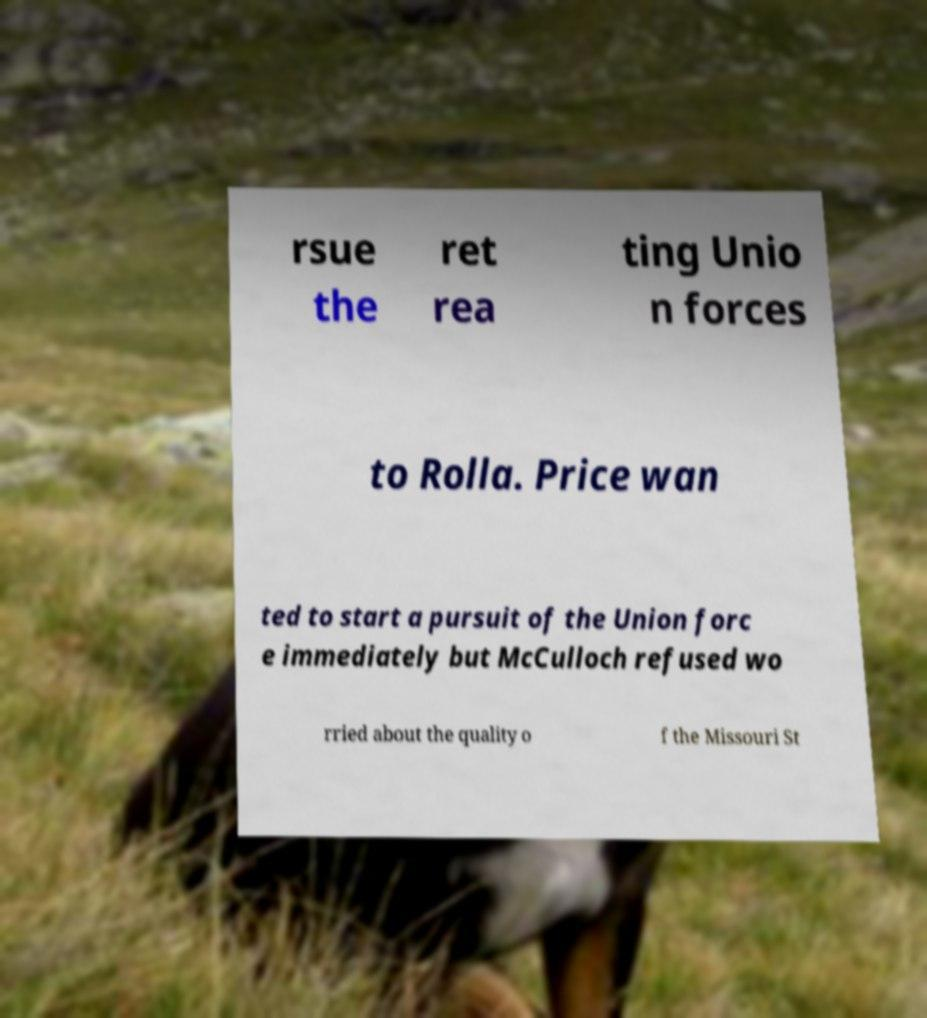Please identify and transcribe the text found in this image. rsue the ret rea ting Unio n forces to Rolla. Price wan ted to start a pursuit of the Union forc e immediately but McCulloch refused wo rried about the quality o f the Missouri St 